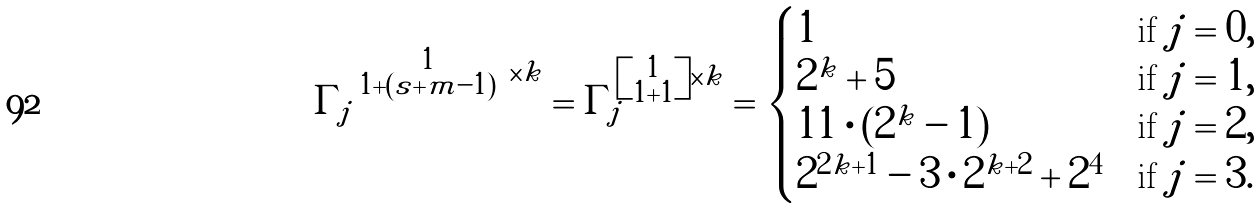<formula> <loc_0><loc_0><loc_500><loc_500>\Gamma _ { j } ^ { \left [ \substack { 1 \\ 1 + ( s + m - 1 ) } \right ] \times k } = \Gamma _ { j } ^ { \left [ \substack { 1 \\ 1 + 1 } \right ] \times k } = \begin{cases} 1 & \text {if } j = 0 , \\ 2 ^ { k } + 5 & \text {if } j = 1 , \\ 1 1 \cdot ( 2 ^ { k } - 1 ) & \text {if  } j = 2 , \\ 2 ^ { 2 k + 1 } - 3 \cdot 2 ^ { k + 2 } + 2 ^ { 4 } & \text {if  } j = 3 . \end{cases}</formula> 